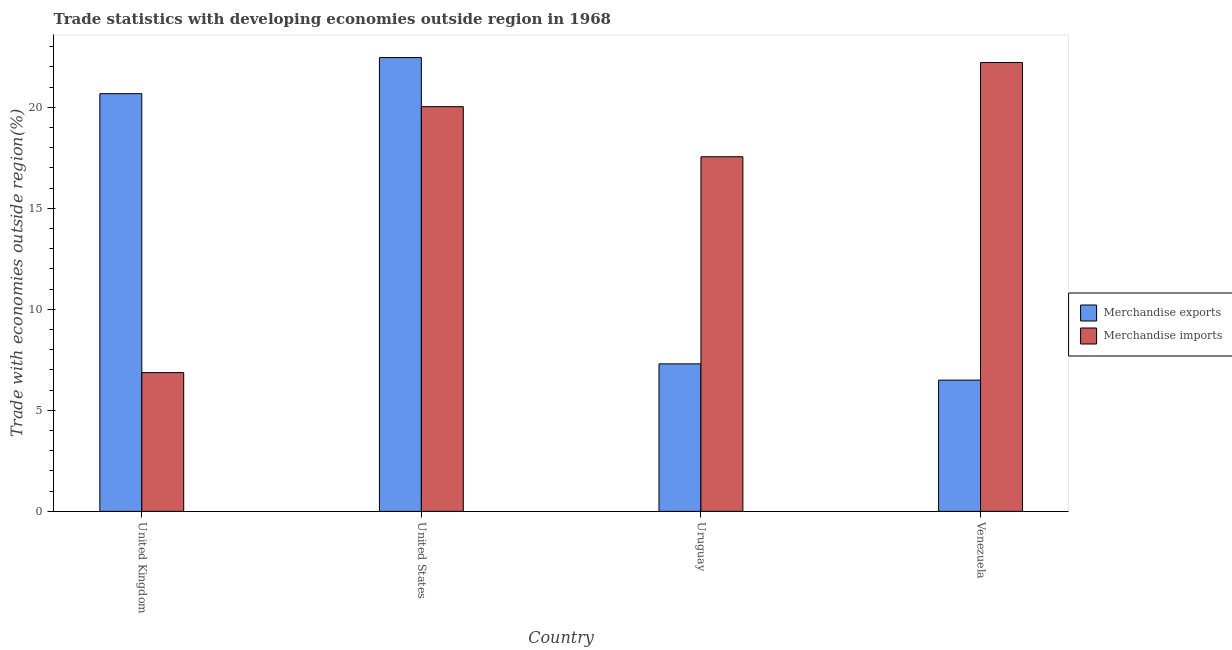How many groups of bars are there?
Provide a short and direct response. 4. Are the number of bars per tick equal to the number of legend labels?
Provide a short and direct response. Yes. Are the number of bars on each tick of the X-axis equal?
Offer a terse response. Yes. How many bars are there on the 4th tick from the left?
Ensure brevity in your answer.  2. How many bars are there on the 2nd tick from the right?
Offer a terse response. 2. What is the label of the 3rd group of bars from the left?
Your response must be concise. Uruguay. In how many cases, is the number of bars for a given country not equal to the number of legend labels?
Offer a terse response. 0. What is the merchandise imports in Venezuela?
Your answer should be compact. 22.22. Across all countries, what is the maximum merchandise imports?
Offer a very short reply. 22.22. Across all countries, what is the minimum merchandise exports?
Offer a very short reply. 6.5. In which country was the merchandise imports maximum?
Offer a very short reply. Venezuela. What is the total merchandise exports in the graph?
Offer a very short reply. 56.93. What is the difference between the merchandise exports in United Kingdom and that in United States?
Ensure brevity in your answer.  -1.79. What is the difference between the merchandise exports in United Kingdom and the merchandise imports in Uruguay?
Your response must be concise. 3.12. What is the average merchandise exports per country?
Provide a short and direct response. 14.23. What is the difference between the merchandise exports and merchandise imports in United States?
Your answer should be compact. 2.43. In how many countries, is the merchandise exports greater than 1 %?
Give a very brief answer. 4. What is the ratio of the merchandise exports in Uruguay to that in Venezuela?
Make the answer very short. 1.12. Is the merchandise imports in United Kingdom less than that in Venezuela?
Offer a very short reply. Yes. Is the difference between the merchandise imports in United States and Venezuela greater than the difference between the merchandise exports in United States and Venezuela?
Your answer should be very brief. No. What is the difference between the highest and the second highest merchandise exports?
Your response must be concise. 1.79. What is the difference between the highest and the lowest merchandise exports?
Offer a terse response. 15.96. In how many countries, is the merchandise exports greater than the average merchandise exports taken over all countries?
Keep it short and to the point. 2. What does the 2nd bar from the left in United Kingdom represents?
Your answer should be compact. Merchandise imports. How many bars are there?
Ensure brevity in your answer.  8. Are all the bars in the graph horizontal?
Your answer should be very brief. No. What is the difference between two consecutive major ticks on the Y-axis?
Your response must be concise. 5. Are the values on the major ticks of Y-axis written in scientific E-notation?
Give a very brief answer. No. Where does the legend appear in the graph?
Provide a succinct answer. Center right. How are the legend labels stacked?
Offer a terse response. Vertical. What is the title of the graph?
Your answer should be compact. Trade statistics with developing economies outside region in 1968. What is the label or title of the Y-axis?
Keep it short and to the point. Trade with economies outside region(%). What is the Trade with economies outside region(%) of Merchandise exports in United Kingdom?
Offer a terse response. 20.67. What is the Trade with economies outside region(%) of Merchandise imports in United Kingdom?
Provide a short and direct response. 6.87. What is the Trade with economies outside region(%) in Merchandise exports in United States?
Provide a succinct answer. 22.46. What is the Trade with economies outside region(%) of Merchandise imports in United States?
Provide a short and direct response. 20.03. What is the Trade with economies outside region(%) in Merchandise exports in Uruguay?
Provide a succinct answer. 7.3. What is the Trade with economies outside region(%) of Merchandise imports in Uruguay?
Your answer should be very brief. 17.55. What is the Trade with economies outside region(%) in Merchandise exports in Venezuela?
Your answer should be very brief. 6.5. What is the Trade with economies outside region(%) of Merchandise imports in Venezuela?
Ensure brevity in your answer.  22.22. Across all countries, what is the maximum Trade with economies outside region(%) in Merchandise exports?
Make the answer very short. 22.46. Across all countries, what is the maximum Trade with economies outside region(%) of Merchandise imports?
Your answer should be compact. 22.22. Across all countries, what is the minimum Trade with economies outside region(%) in Merchandise exports?
Your answer should be compact. 6.5. Across all countries, what is the minimum Trade with economies outside region(%) in Merchandise imports?
Provide a succinct answer. 6.87. What is the total Trade with economies outside region(%) of Merchandise exports in the graph?
Your answer should be very brief. 56.93. What is the total Trade with economies outside region(%) of Merchandise imports in the graph?
Your answer should be very brief. 66.66. What is the difference between the Trade with economies outside region(%) of Merchandise exports in United Kingdom and that in United States?
Make the answer very short. -1.79. What is the difference between the Trade with economies outside region(%) of Merchandise imports in United Kingdom and that in United States?
Your answer should be very brief. -13.16. What is the difference between the Trade with economies outside region(%) in Merchandise exports in United Kingdom and that in Uruguay?
Provide a succinct answer. 13.37. What is the difference between the Trade with economies outside region(%) of Merchandise imports in United Kingdom and that in Uruguay?
Offer a terse response. -10.68. What is the difference between the Trade with economies outside region(%) in Merchandise exports in United Kingdom and that in Venezuela?
Provide a succinct answer. 14.18. What is the difference between the Trade with economies outside region(%) of Merchandise imports in United Kingdom and that in Venezuela?
Ensure brevity in your answer.  -15.35. What is the difference between the Trade with economies outside region(%) of Merchandise exports in United States and that in Uruguay?
Your response must be concise. 15.16. What is the difference between the Trade with economies outside region(%) in Merchandise imports in United States and that in Uruguay?
Provide a short and direct response. 2.48. What is the difference between the Trade with economies outside region(%) of Merchandise exports in United States and that in Venezuela?
Offer a terse response. 15.96. What is the difference between the Trade with economies outside region(%) in Merchandise imports in United States and that in Venezuela?
Your response must be concise. -2.18. What is the difference between the Trade with economies outside region(%) in Merchandise exports in Uruguay and that in Venezuela?
Provide a short and direct response. 0.8. What is the difference between the Trade with economies outside region(%) of Merchandise imports in Uruguay and that in Venezuela?
Give a very brief answer. -4.66. What is the difference between the Trade with economies outside region(%) of Merchandise exports in United Kingdom and the Trade with economies outside region(%) of Merchandise imports in United States?
Provide a short and direct response. 0.64. What is the difference between the Trade with economies outside region(%) in Merchandise exports in United Kingdom and the Trade with economies outside region(%) in Merchandise imports in Uruguay?
Ensure brevity in your answer.  3.12. What is the difference between the Trade with economies outside region(%) of Merchandise exports in United Kingdom and the Trade with economies outside region(%) of Merchandise imports in Venezuela?
Ensure brevity in your answer.  -1.54. What is the difference between the Trade with economies outside region(%) in Merchandise exports in United States and the Trade with economies outside region(%) in Merchandise imports in Uruguay?
Make the answer very short. 4.91. What is the difference between the Trade with economies outside region(%) of Merchandise exports in United States and the Trade with economies outside region(%) of Merchandise imports in Venezuela?
Your response must be concise. 0.25. What is the difference between the Trade with economies outside region(%) in Merchandise exports in Uruguay and the Trade with economies outside region(%) in Merchandise imports in Venezuela?
Offer a terse response. -14.91. What is the average Trade with economies outside region(%) in Merchandise exports per country?
Give a very brief answer. 14.23. What is the average Trade with economies outside region(%) of Merchandise imports per country?
Ensure brevity in your answer.  16.67. What is the difference between the Trade with economies outside region(%) of Merchandise exports and Trade with economies outside region(%) of Merchandise imports in United Kingdom?
Provide a succinct answer. 13.81. What is the difference between the Trade with economies outside region(%) of Merchandise exports and Trade with economies outside region(%) of Merchandise imports in United States?
Ensure brevity in your answer.  2.43. What is the difference between the Trade with economies outside region(%) in Merchandise exports and Trade with economies outside region(%) in Merchandise imports in Uruguay?
Make the answer very short. -10.25. What is the difference between the Trade with economies outside region(%) of Merchandise exports and Trade with economies outside region(%) of Merchandise imports in Venezuela?
Offer a terse response. -15.72. What is the ratio of the Trade with economies outside region(%) in Merchandise exports in United Kingdom to that in United States?
Keep it short and to the point. 0.92. What is the ratio of the Trade with economies outside region(%) of Merchandise imports in United Kingdom to that in United States?
Make the answer very short. 0.34. What is the ratio of the Trade with economies outside region(%) in Merchandise exports in United Kingdom to that in Uruguay?
Provide a succinct answer. 2.83. What is the ratio of the Trade with economies outside region(%) of Merchandise imports in United Kingdom to that in Uruguay?
Your answer should be very brief. 0.39. What is the ratio of the Trade with economies outside region(%) in Merchandise exports in United Kingdom to that in Venezuela?
Provide a short and direct response. 3.18. What is the ratio of the Trade with economies outside region(%) of Merchandise imports in United Kingdom to that in Venezuela?
Your answer should be very brief. 0.31. What is the ratio of the Trade with economies outside region(%) of Merchandise exports in United States to that in Uruguay?
Your response must be concise. 3.08. What is the ratio of the Trade with economies outside region(%) of Merchandise imports in United States to that in Uruguay?
Offer a very short reply. 1.14. What is the ratio of the Trade with economies outside region(%) of Merchandise exports in United States to that in Venezuela?
Provide a succinct answer. 3.46. What is the ratio of the Trade with economies outside region(%) of Merchandise imports in United States to that in Venezuela?
Your answer should be compact. 0.9. What is the ratio of the Trade with economies outside region(%) in Merchandise exports in Uruguay to that in Venezuela?
Offer a very short reply. 1.12. What is the ratio of the Trade with economies outside region(%) in Merchandise imports in Uruguay to that in Venezuela?
Provide a short and direct response. 0.79. What is the difference between the highest and the second highest Trade with economies outside region(%) of Merchandise exports?
Offer a very short reply. 1.79. What is the difference between the highest and the second highest Trade with economies outside region(%) in Merchandise imports?
Make the answer very short. 2.18. What is the difference between the highest and the lowest Trade with economies outside region(%) of Merchandise exports?
Offer a very short reply. 15.96. What is the difference between the highest and the lowest Trade with economies outside region(%) in Merchandise imports?
Keep it short and to the point. 15.35. 